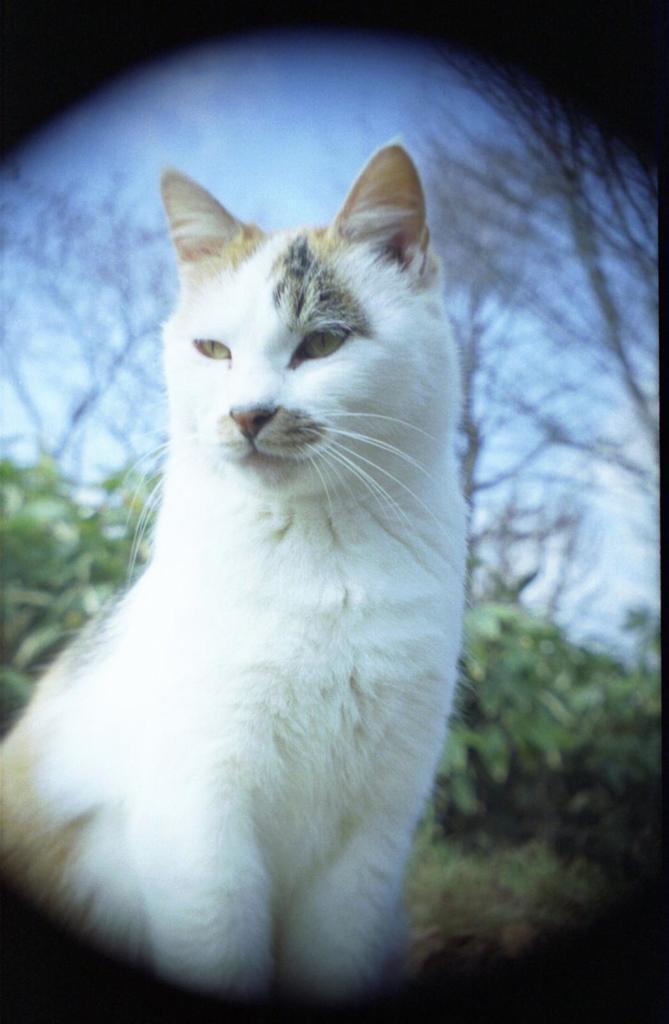How would you summarize this image in a sentence or two? In this picture I can observe white color cat. In the background there are plants, trees and a sky. 